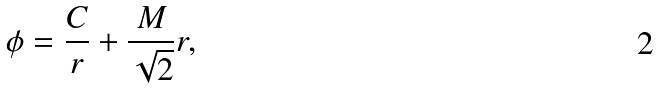<formula> <loc_0><loc_0><loc_500><loc_500>\phi = \frac { C } { r } + \frac { M } { \sqrt { 2 } } r ,</formula> 